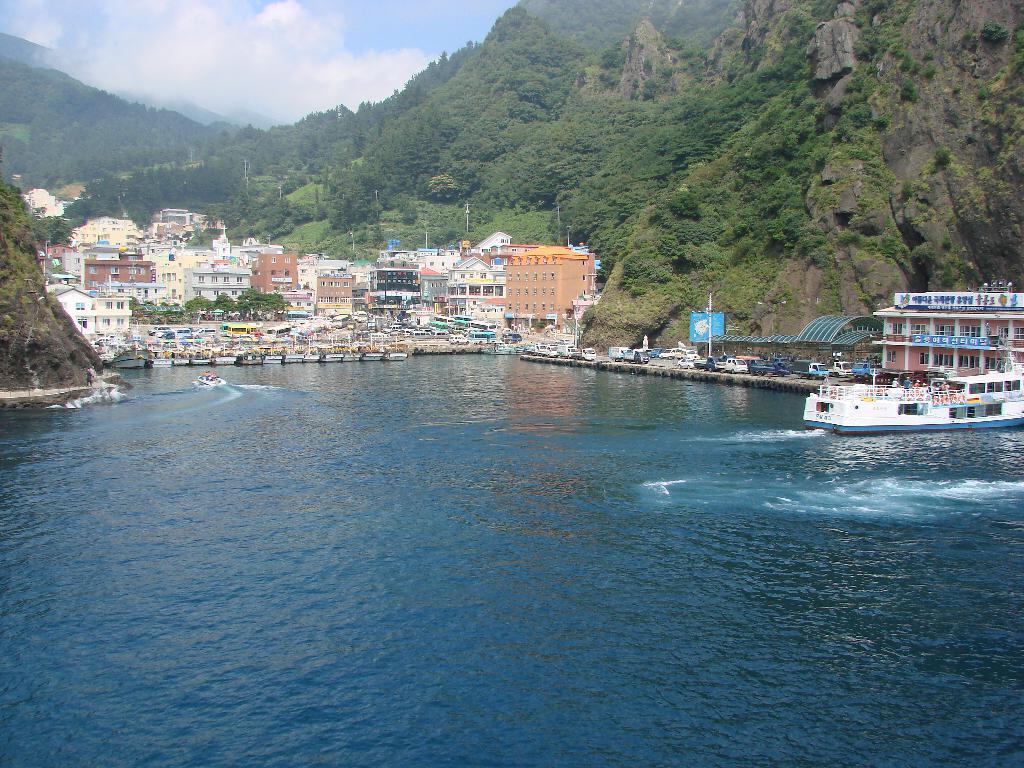How would you summarize this image in a sentence or two? In this image we can see boats on the water, there are few buildings, vehicles on the ground, few trees, mountains and the sky with clouds in the background. 